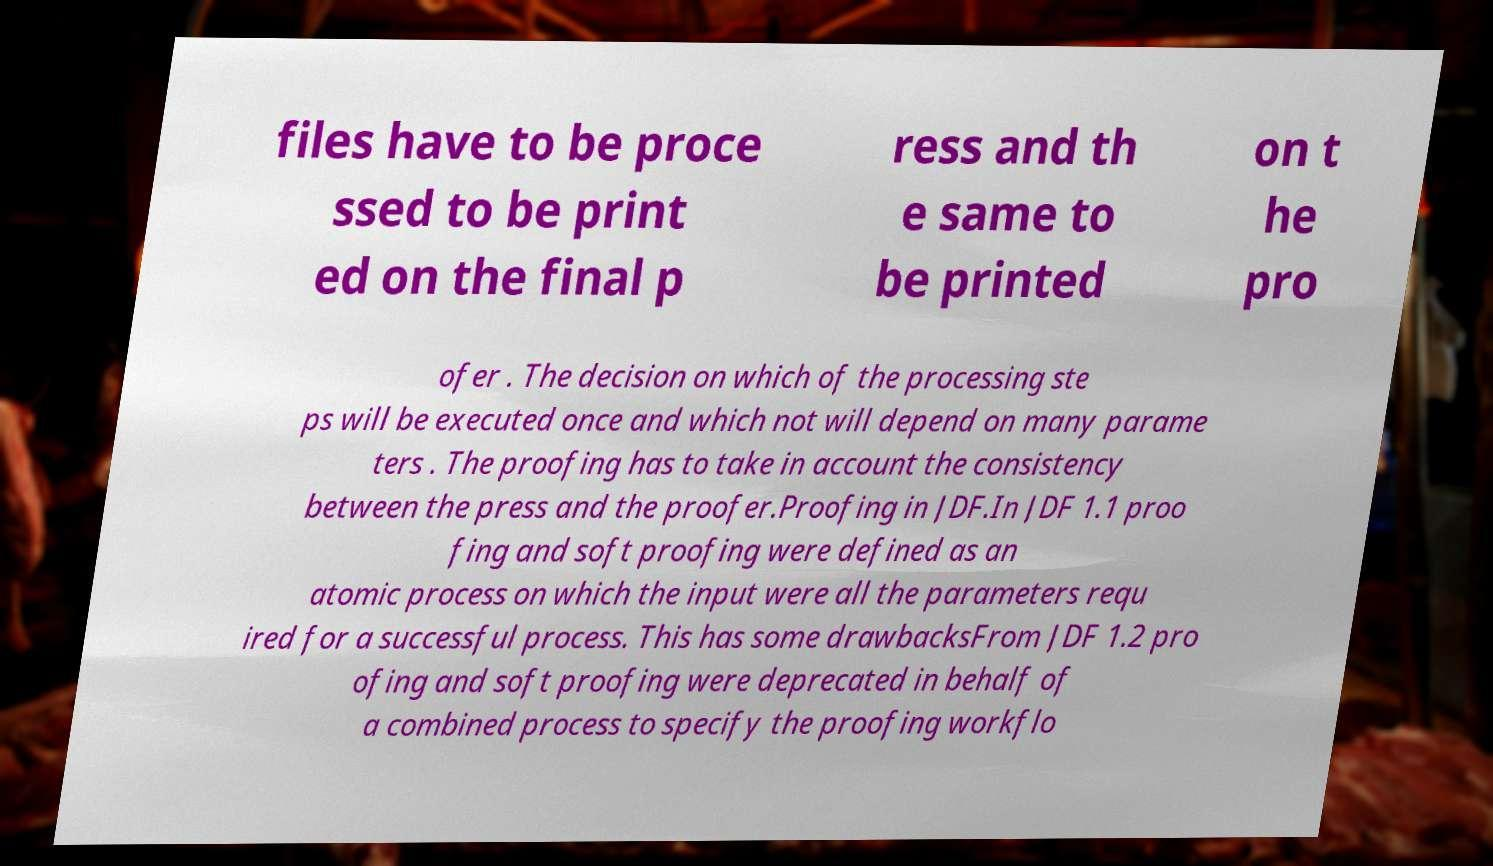Can you accurately transcribe the text from the provided image for me? files have to be proce ssed to be print ed on the final p ress and th e same to be printed on t he pro ofer . The decision on which of the processing ste ps will be executed once and which not will depend on many parame ters . The proofing has to take in account the consistency between the press and the proofer.Proofing in JDF.In JDF 1.1 proo fing and soft proofing were defined as an atomic process on which the input were all the parameters requ ired for a successful process. This has some drawbacksFrom JDF 1.2 pro ofing and soft proofing were deprecated in behalf of a combined process to specify the proofing workflo 